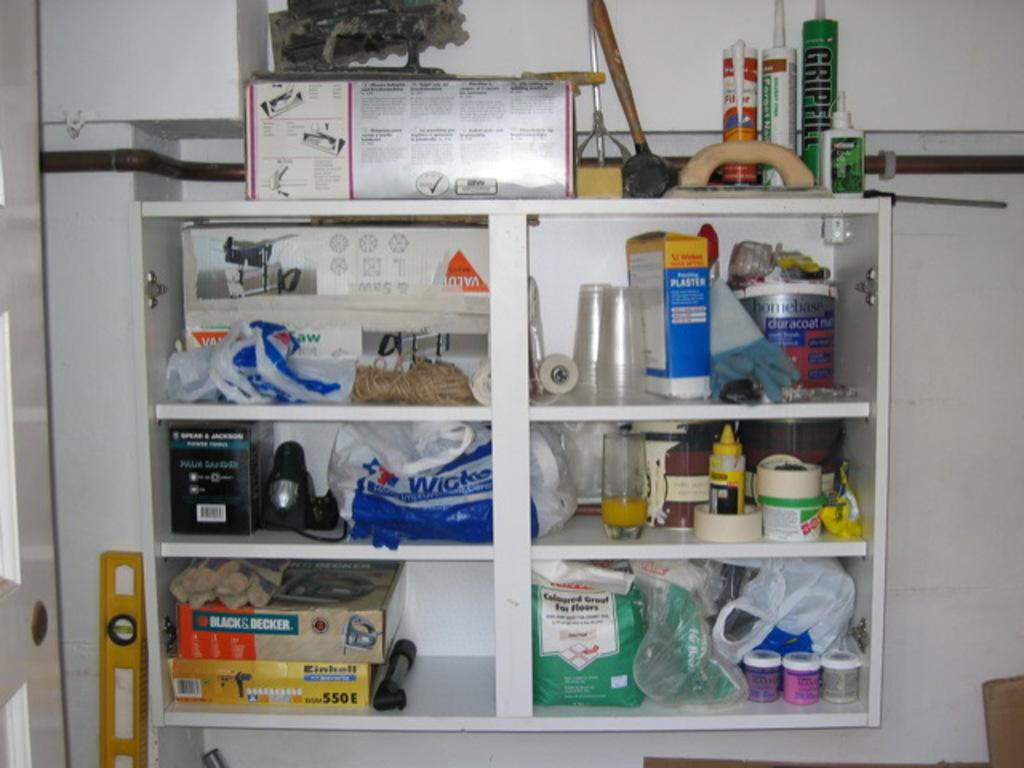<image>
Share a concise interpretation of the image provided. A shelf with various items including a Black and Decker box and a gripfill tube on it. 